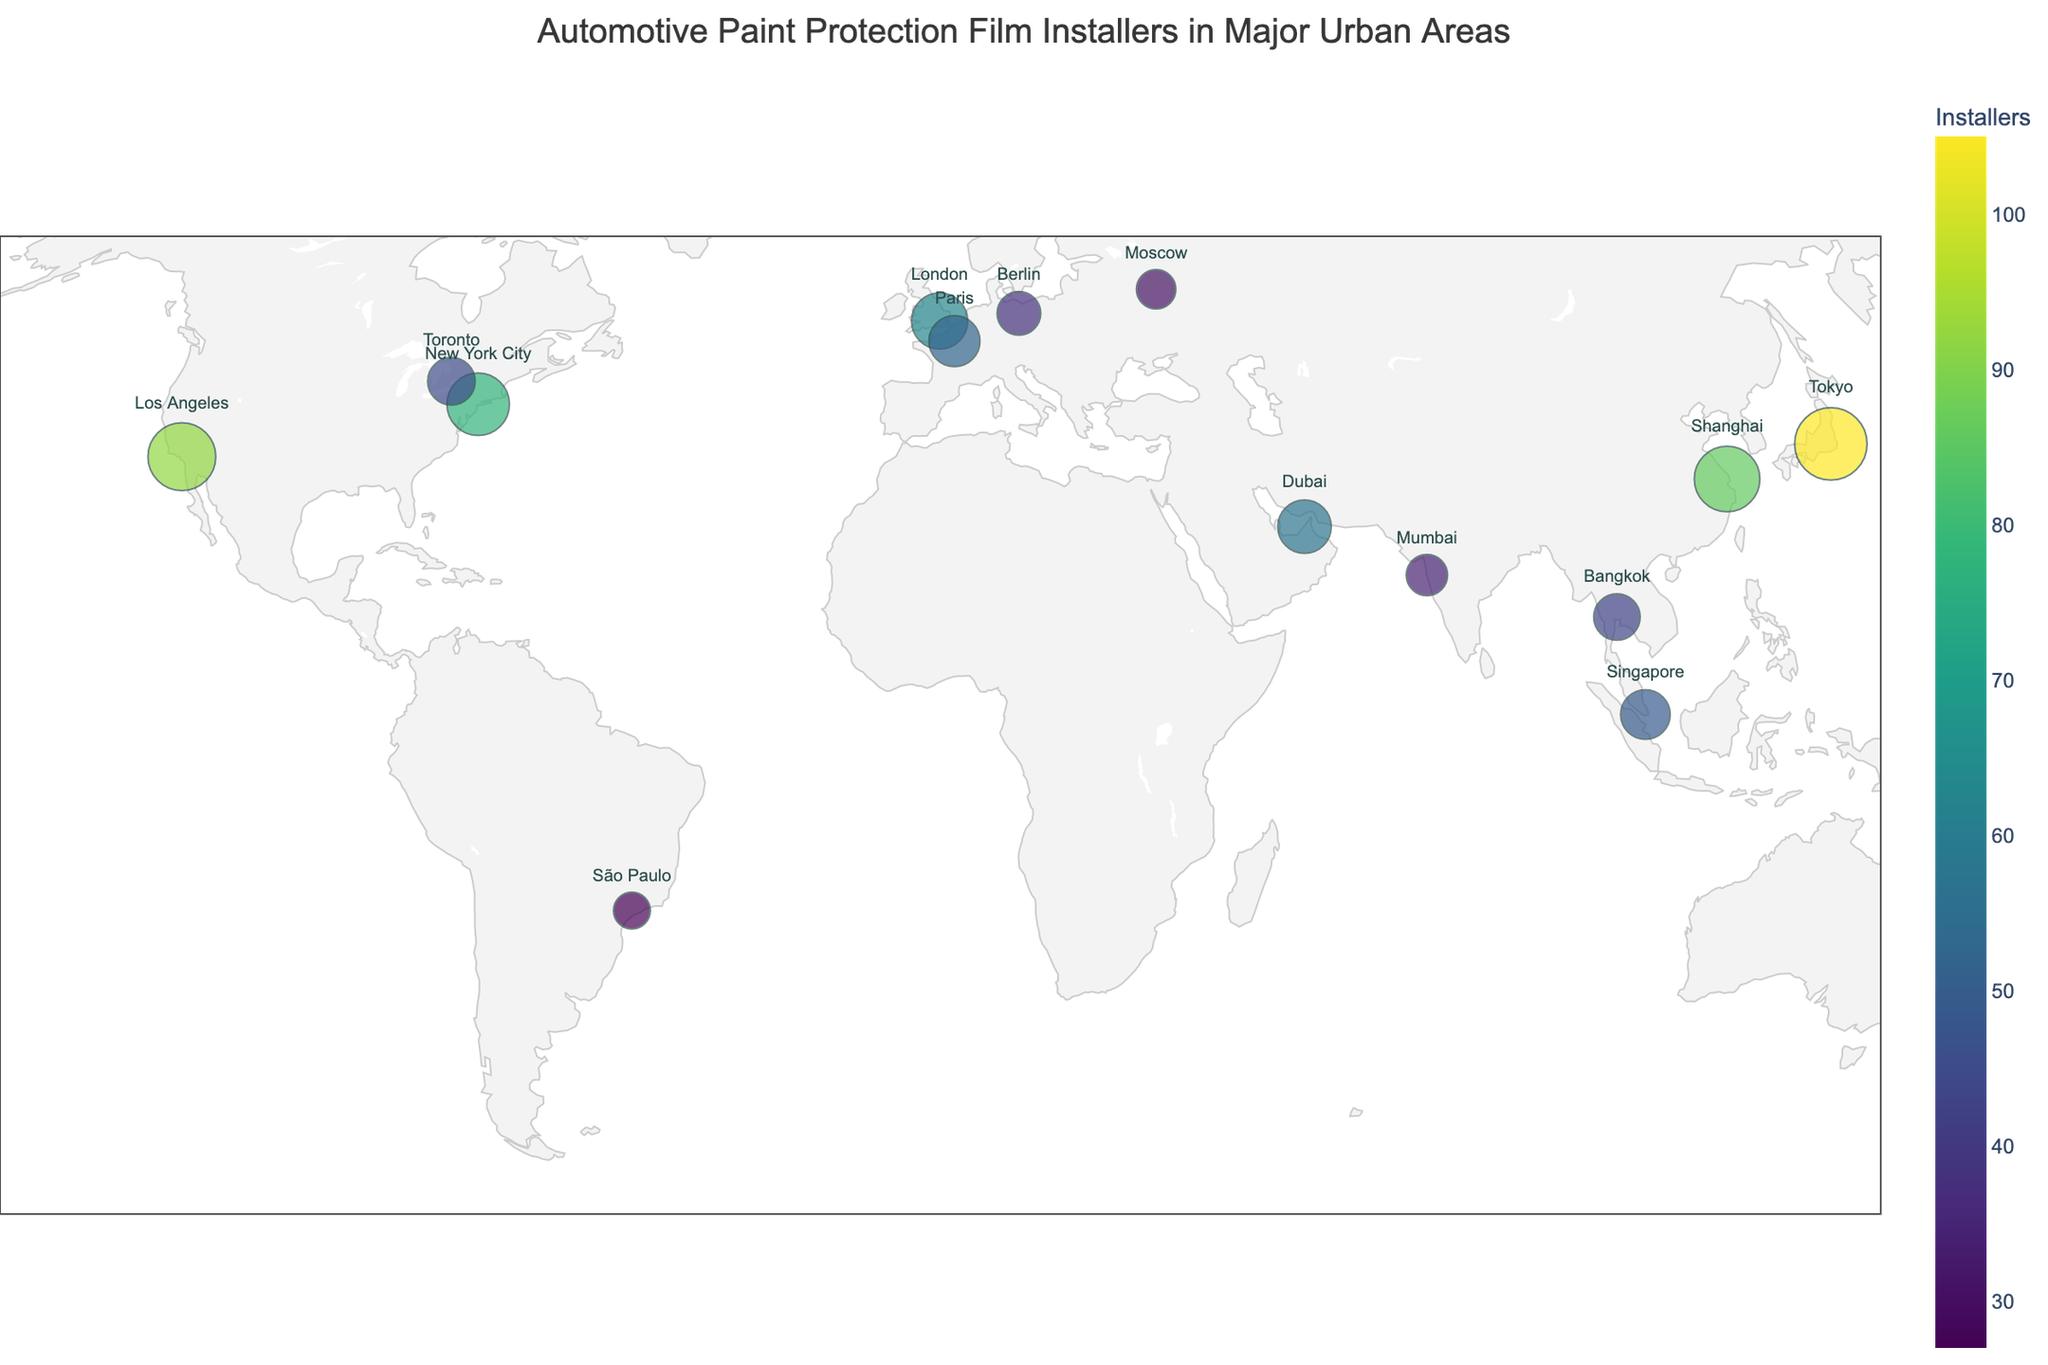what does the title of the plot say? The title of the plot is located at the top of the figure and often provides a summary of what the plot displays.
Answer: Automotive Paint Protection Film Installers in Major Urban Areas How many installers are there in Sydney and Dubai combined? Sydney has 41 installers, and Dubai has 57 installers. Adding these numbers gives a total of 41 + 57 = 98.
Answer: 98 Which city has the largest number of installers? By examining the size of the data points and the color intensity, Tokyo has the largest number of installers, which is 105.
Answer: Tokyo Do Paris and Toronto have the same number of installers? To answer this, compare the number of installers in both cities. Paris has 52 installers, while Toronto has 45 installers, so they do not have the same number of installers.
Answer: No Is the point for São Paulo located in the Southern Hemisphere? São Paulo's latitude is -23.5505, and any negative latitude indicates a position in the Southern Hemisphere.
Answer: Yes What is the approximate size of the largest data point in the plot representing Tokyo? The size of data points correlates with the number of installers. Since Tokyo has the highest count of 105 installers, its data point is the largest on the plot with size near the maximum of 30.
Answer: Near 30 What's the range in the number of installers across all cities? Identify the maximum and minimum values from the dataset. The highest is 105 (Tokyo) and the lowest is 27 (São Paulo), so the range is 105 - 27 = 78.
Answer: 78 Which city has more installers, Los Angeles or Shanghai? Los Angeles has 92 installers, and Shanghai has 86 installers, so Los Angeles has more installers.
Answer: Los Angeles Among the listed cities, which one is the furthest north? By inspecting the latitudes, Moscow, with a latitude of 55.7558, is the furthest north among the cities listed.
Answer: Moscow What is the average number of installers in the listed cities? Sum all the installers and divide by the number of cities. The total number is 741 (sum of all installers), and there are 15 cities. So, the average is 741 / 15 ≈ 49.4.
Answer: Approx. 49.4 